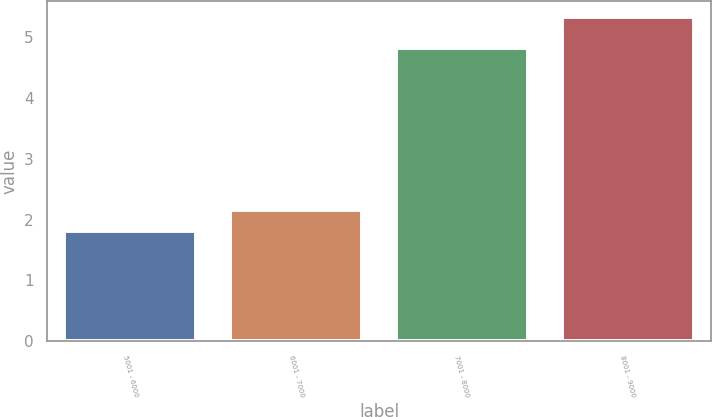Convert chart to OTSL. <chart><loc_0><loc_0><loc_500><loc_500><bar_chart><fcel>5001 - 6000<fcel>6001 - 7000<fcel>7001 - 8000<fcel>8001 - 9000<nl><fcel>1.81<fcel>2.16<fcel>4.82<fcel>5.33<nl></chart> 